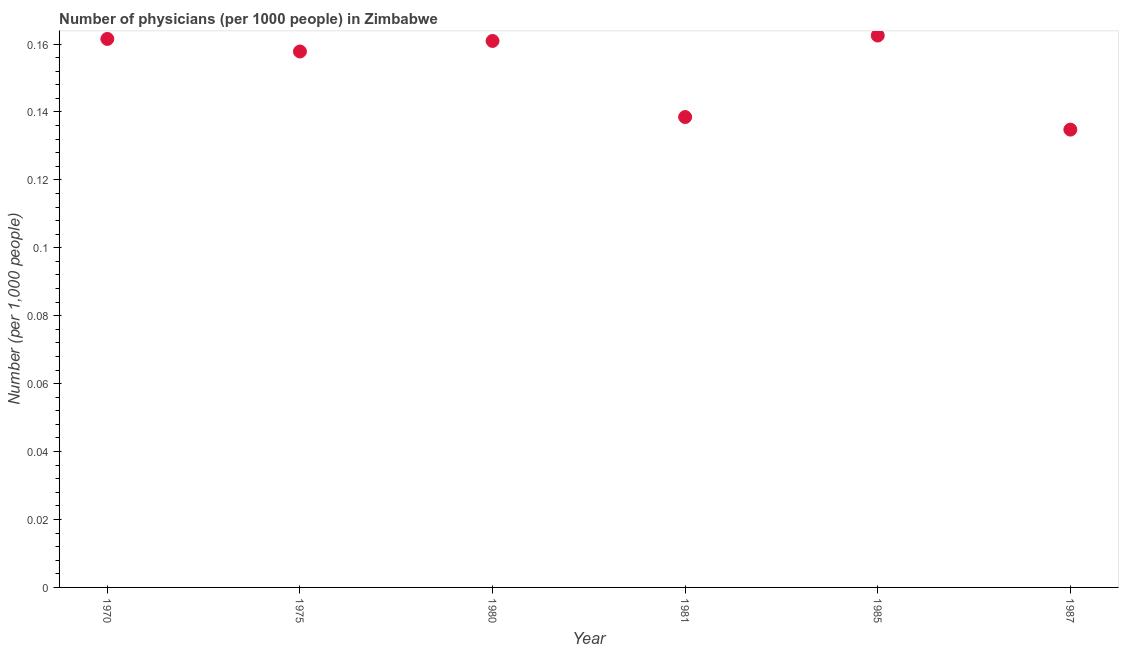What is the number of physicians in 1987?
Give a very brief answer. 0.13. Across all years, what is the maximum number of physicians?
Ensure brevity in your answer.  0.16. Across all years, what is the minimum number of physicians?
Your answer should be compact. 0.13. In which year was the number of physicians maximum?
Provide a short and direct response. 1985. In which year was the number of physicians minimum?
Your response must be concise. 1987. What is the sum of the number of physicians?
Your response must be concise. 0.92. What is the difference between the number of physicians in 1970 and 1985?
Your response must be concise. -0. What is the average number of physicians per year?
Offer a very short reply. 0.15. What is the median number of physicians?
Offer a very short reply. 0.16. In how many years, is the number of physicians greater than 0.15200000000000002 ?
Ensure brevity in your answer.  4. What is the ratio of the number of physicians in 1975 to that in 1987?
Give a very brief answer. 1.17. Is the number of physicians in 1981 less than that in 1987?
Provide a short and direct response. No. What is the difference between the highest and the second highest number of physicians?
Make the answer very short. 0. Is the sum of the number of physicians in 1970 and 1981 greater than the maximum number of physicians across all years?
Provide a succinct answer. Yes. What is the difference between the highest and the lowest number of physicians?
Your answer should be compact. 0.03. In how many years, is the number of physicians greater than the average number of physicians taken over all years?
Ensure brevity in your answer.  4. What is the difference between two consecutive major ticks on the Y-axis?
Make the answer very short. 0.02. Are the values on the major ticks of Y-axis written in scientific E-notation?
Ensure brevity in your answer.  No. Does the graph contain grids?
Offer a terse response. No. What is the title of the graph?
Your answer should be very brief. Number of physicians (per 1000 people) in Zimbabwe. What is the label or title of the X-axis?
Make the answer very short. Year. What is the label or title of the Y-axis?
Offer a very short reply. Number (per 1,0 people). What is the Number (per 1,000 people) in 1970?
Ensure brevity in your answer.  0.16. What is the Number (per 1,000 people) in 1975?
Ensure brevity in your answer.  0.16. What is the Number (per 1,000 people) in 1980?
Provide a short and direct response. 0.16. What is the Number (per 1,000 people) in 1981?
Keep it short and to the point. 0.14. What is the Number (per 1,000 people) in 1985?
Provide a short and direct response. 0.16. What is the Number (per 1,000 people) in 1987?
Keep it short and to the point. 0.13. What is the difference between the Number (per 1,000 people) in 1970 and 1975?
Provide a short and direct response. 0. What is the difference between the Number (per 1,000 people) in 1970 and 1980?
Your answer should be very brief. 0. What is the difference between the Number (per 1,000 people) in 1970 and 1981?
Your answer should be very brief. 0.02. What is the difference between the Number (per 1,000 people) in 1970 and 1985?
Provide a short and direct response. -0. What is the difference between the Number (per 1,000 people) in 1970 and 1987?
Keep it short and to the point. 0.03. What is the difference between the Number (per 1,000 people) in 1975 and 1980?
Give a very brief answer. -0. What is the difference between the Number (per 1,000 people) in 1975 and 1981?
Provide a succinct answer. 0.02. What is the difference between the Number (per 1,000 people) in 1975 and 1985?
Provide a succinct answer. -0. What is the difference between the Number (per 1,000 people) in 1975 and 1987?
Provide a succinct answer. 0.02. What is the difference between the Number (per 1,000 people) in 1980 and 1981?
Make the answer very short. 0.02. What is the difference between the Number (per 1,000 people) in 1980 and 1985?
Your answer should be compact. -0. What is the difference between the Number (per 1,000 people) in 1980 and 1987?
Your answer should be compact. 0.03. What is the difference between the Number (per 1,000 people) in 1981 and 1985?
Your answer should be very brief. -0.02. What is the difference between the Number (per 1,000 people) in 1981 and 1987?
Make the answer very short. 0. What is the difference between the Number (per 1,000 people) in 1985 and 1987?
Give a very brief answer. 0.03. What is the ratio of the Number (per 1,000 people) in 1970 to that in 1975?
Provide a succinct answer. 1.02. What is the ratio of the Number (per 1,000 people) in 1970 to that in 1981?
Your response must be concise. 1.17. What is the ratio of the Number (per 1,000 people) in 1970 to that in 1987?
Keep it short and to the point. 1.2. What is the ratio of the Number (per 1,000 people) in 1975 to that in 1981?
Offer a very short reply. 1.14. What is the ratio of the Number (per 1,000 people) in 1975 to that in 1985?
Provide a short and direct response. 0.97. What is the ratio of the Number (per 1,000 people) in 1975 to that in 1987?
Your answer should be very brief. 1.17. What is the ratio of the Number (per 1,000 people) in 1980 to that in 1981?
Your response must be concise. 1.16. What is the ratio of the Number (per 1,000 people) in 1980 to that in 1985?
Keep it short and to the point. 0.99. What is the ratio of the Number (per 1,000 people) in 1980 to that in 1987?
Offer a terse response. 1.19. What is the ratio of the Number (per 1,000 people) in 1981 to that in 1985?
Your answer should be very brief. 0.85. What is the ratio of the Number (per 1,000 people) in 1981 to that in 1987?
Provide a short and direct response. 1.03. What is the ratio of the Number (per 1,000 people) in 1985 to that in 1987?
Keep it short and to the point. 1.21. 